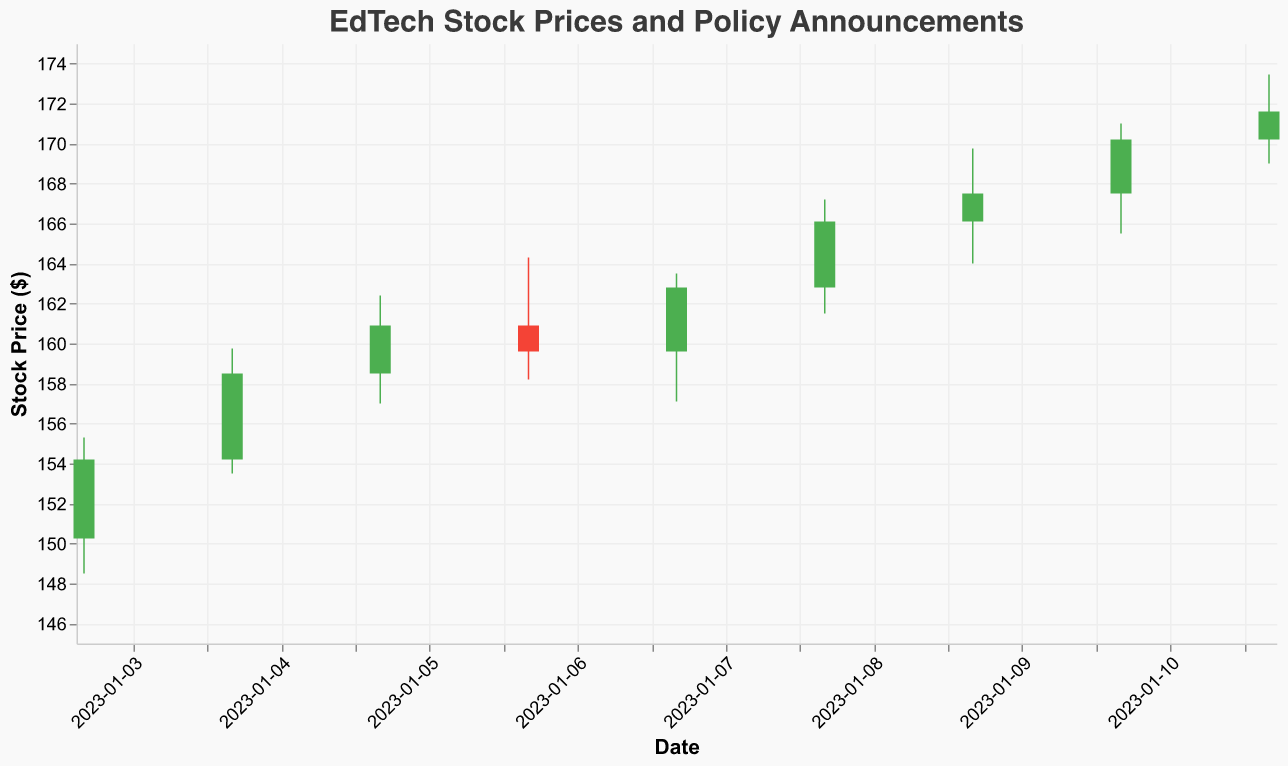What's the overall trend in the stock prices from January 3 to January 11? By examining the candlestick plot, we can observe the pattern of the daily opening, high, low, and closing prices. The general trend shows an increase in the stock prices over the specified period.
Answer: Increasing Which EdTech company experienced the highest closing price within this period? Looking at the candlesticks' closing prices segment, we see that Codecademy reached the highest closing price of $170.20 on January 10.
Answer: Codecademy What is the date and the closing price of the lowest stock price achieved? To find the lowest closing price, we examine the candlestick plot. The lowest closing price of $154.20 occurred on January 3 (Coursera).
Answer: January 3, $154.20 Which company had the largest difference between the high and low price on their respective announcement date? By comparing the high and low prices for each day, we find that edX had the largest difference ($169.75 - $164.00 = $5.75) on January 9.
Answer: edX Between January 8 and January 9, which EdTech company showed a higher increase in closing price, Duolingo or edX? On January 8, Duolingo closed at $166.10 while on January 9, edX closed at $167.50. So, the increase was $167.50 - $166.10 = $1.40. Duolingo closed at the same price it opened. Therefore, edX had a higher increase of $1.40.
Answer: edX How did the stock price trend for Khan Academy on the day of their policy announcement? By looking at the candlestick for January 6, the data shows the opening price was $160.90 and the closing price was $159.60, indicating a slight decrease during the day.
Answer: Decreasing Calculate the average closing price over the 9 days shown in the candlestick plot. Add up all the closing prices from January 3 to January 11 ($154.20 + $158.50 + $160.90 + $159.60 + $162.80 + $166.10 + $167.50 + $170.20 + $171.60) and divide by the number of days (9) to find the average. The sum is $1471.4, so the average is $1471.4 / 9.
Answer: $163.49 Which company had the narrowest range between their high and low prices? By calculating the range (High - Low) for each day and comparing them, we find that Coursera had the narrowest range of $155.30 - $148.50 = $6.80 on January 3.
Answer: Coursera 